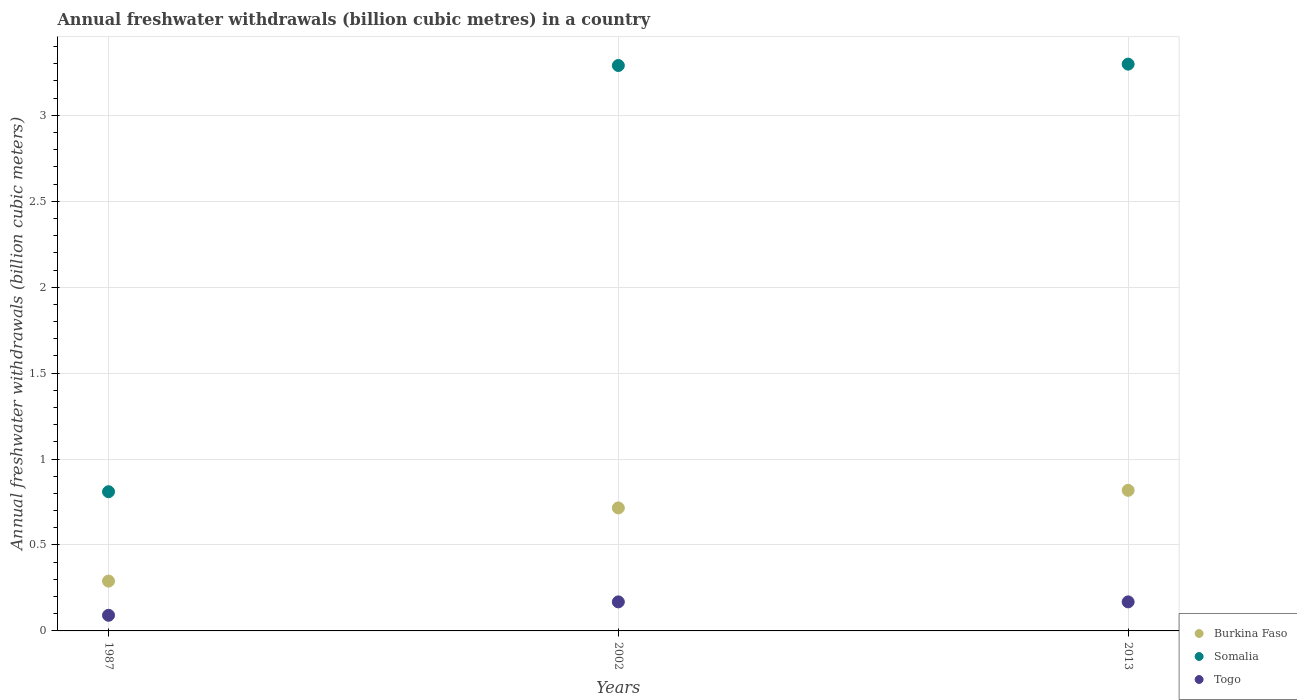What is the annual freshwater withdrawals in Burkina Faso in 2013?
Provide a succinct answer. 0.82. Across all years, what is the maximum annual freshwater withdrawals in Burkina Faso?
Offer a very short reply. 0.82. Across all years, what is the minimum annual freshwater withdrawals in Somalia?
Your answer should be very brief. 0.81. What is the total annual freshwater withdrawals in Somalia in the graph?
Provide a short and direct response. 7.4. What is the difference between the annual freshwater withdrawals in Somalia in 1987 and that in 2002?
Provide a succinct answer. -2.48. What is the difference between the annual freshwater withdrawals in Somalia in 2002 and the annual freshwater withdrawals in Togo in 2013?
Offer a very short reply. 3.12. What is the average annual freshwater withdrawals in Somalia per year?
Your answer should be compact. 2.47. In the year 2013, what is the difference between the annual freshwater withdrawals in Somalia and annual freshwater withdrawals in Togo?
Give a very brief answer. 3.13. What is the ratio of the annual freshwater withdrawals in Burkina Faso in 2002 to that in 2013?
Offer a very short reply. 0.87. Is the annual freshwater withdrawals in Somalia in 1987 less than that in 2002?
Your response must be concise. Yes. Is the difference between the annual freshwater withdrawals in Somalia in 1987 and 2013 greater than the difference between the annual freshwater withdrawals in Togo in 1987 and 2013?
Offer a terse response. No. What is the difference between the highest and the second highest annual freshwater withdrawals in Togo?
Offer a very short reply. 0. What is the difference between the highest and the lowest annual freshwater withdrawals in Togo?
Offer a very short reply. 0.08. In how many years, is the annual freshwater withdrawals in Somalia greater than the average annual freshwater withdrawals in Somalia taken over all years?
Give a very brief answer. 2. Is the annual freshwater withdrawals in Somalia strictly greater than the annual freshwater withdrawals in Burkina Faso over the years?
Offer a very short reply. Yes. How many years are there in the graph?
Give a very brief answer. 3. What is the difference between two consecutive major ticks on the Y-axis?
Offer a very short reply. 0.5. Are the values on the major ticks of Y-axis written in scientific E-notation?
Your answer should be very brief. No. Does the graph contain any zero values?
Your answer should be compact. No. Does the graph contain grids?
Ensure brevity in your answer.  Yes. What is the title of the graph?
Make the answer very short. Annual freshwater withdrawals (billion cubic metres) in a country. Does "Ireland" appear as one of the legend labels in the graph?
Your response must be concise. No. What is the label or title of the Y-axis?
Provide a short and direct response. Annual freshwater withdrawals (billion cubic meters). What is the Annual freshwater withdrawals (billion cubic meters) in Burkina Faso in 1987?
Make the answer very short. 0.29. What is the Annual freshwater withdrawals (billion cubic meters) of Somalia in 1987?
Offer a very short reply. 0.81. What is the Annual freshwater withdrawals (billion cubic meters) in Togo in 1987?
Keep it short and to the point. 0.09. What is the Annual freshwater withdrawals (billion cubic meters) in Burkina Faso in 2002?
Ensure brevity in your answer.  0.72. What is the Annual freshwater withdrawals (billion cubic meters) of Somalia in 2002?
Give a very brief answer. 3.29. What is the Annual freshwater withdrawals (billion cubic meters) in Togo in 2002?
Offer a terse response. 0.17. What is the Annual freshwater withdrawals (billion cubic meters) of Burkina Faso in 2013?
Provide a succinct answer. 0.82. What is the Annual freshwater withdrawals (billion cubic meters) of Somalia in 2013?
Your answer should be very brief. 3.3. What is the Annual freshwater withdrawals (billion cubic meters) of Togo in 2013?
Your answer should be very brief. 0.17. Across all years, what is the maximum Annual freshwater withdrawals (billion cubic meters) of Burkina Faso?
Provide a short and direct response. 0.82. Across all years, what is the maximum Annual freshwater withdrawals (billion cubic meters) of Somalia?
Your response must be concise. 3.3. Across all years, what is the maximum Annual freshwater withdrawals (billion cubic meters) of Togo?
Your answer should be very brief. 0.17. Across all years, what is the minimum Annual freshwater withdrawals (billion cubic meters) of Burkina Faso?
Provide a short and direct response. 0.29. Across all years, what is the minimum Annual freshwater withdrawals (billion cubic meters) of Somalia?
Ensure brevity in your answer.  0.81. Across all years, what is the minimum Annual freshwater withdrawals (billion cubic meters) in Togo?
Provide a succinct answer. 0.09. What is the total Annual freshwater withdrawals (billion cubic meters) in Burkina Faso in the graph?
Your response must be concise. 1.82. What is the total Annual freshwater withdrawals (billion cubic meters) of Somalia in the graph?
Your answer should be very brief. 7.4. What is the total Annual freshwater withdrawals (billion cubic meters) in Togo in the graph?
Keep it short and to the point. 0.43. What is the difference between the Annual freshwater withdrawals (billion cubic meters) of Burkina Faso in 1987 and that in 2002?
Keep it short and to the point. -0.43. What is the difference between the Annual freshwater withdrawals (billion cubic meters) of Somalia in 1987 and that in 2002?
Your answer should be compact. -2.48. What is the difference between the Annual freshwater withdrawals (billion cubic meters) of Togo in 1987 and that in 2002?
Your answer should be very brief. -0.08. What is the difference between the Annual freshwater withdrawals (billion cubic meters) of Burkina Faso in 1987 and that in 2013?
Offer a very short reply. -0.53. What is the difference between the Annual freshwater withdrawals (billion cubic meters) of Somalia in 1987 and that in 2013?
Keep it short and to the point. -2.49. What is the difference between the Annual freshwater withdrawals (billion cubic meters) of Togo in 1987 and that in 2013?
Your answer should be compact. -0.08. What is the difference between the Annual freshwater withdrawals (billion cubic meters) of Burkina Faso in 2002 and that in 2013?
Provide a succinct answer. -0.1. What is the difference between the Annual freshwater withdrawals (billion cubic meters) in Somalia in 2002 and that in 2013?
Your answer should be very brief. -0.01. What is the difference between the Annual freshwater withdrawals (billion cubic meters) of Togo in 2002 and that in 2013?
Give a very brief answer. 0. What is the difference between the Annual freshwater withdrawals (billion cubic meters) of Burkina Faso in 1987 and the Annual freshwater withdrawals (billion cubic meters) of Somalia in 2002?
Make the answer very short. -3. What is the difference between the Annual freshwater withdrawals (billion cubic meters) in Burkina Faso in 1987 and the Annual freshwater withdrawals (billion cubic meters) in Togo in 2002?
Provide a succinct answer. 0.12. What is the difference between the Annual freshwater withdrawals (billion cubic meters) in Somalia in 1987 and the Annual freshwater withdrawals (billion cubic meters) in Togo in 2002?
Your answer should be very brief. 0.64. What is the difference between the Annual freshwater withdrawals (billion cubic meters) in Burkina Faso in 1987 and the Annual freshwater withdrawals (billion cubic meters) in Somalia in 2013?
Make the answer very short. -3.01. What is the difference between the Annual freshwater withdrawals (billion cubic meters) of Burkina Faso in 1987 and the Annual freshwater withdrawals (billion cubic meters) of Togo in 2013?
Keep it short and to the point. 0.12. What is the difference between the Annual freshwater withdrawals (billion cubic meters) in Somalia in 1987 and the Annual freshwater withdrawals (billion cubic meters) in Togo in 2013?
Your answer should be compact. 0.64. What is the difference between the Annual freshwater withdrawals (billion cubic meters) of Burkina Faso in 2002 and the Annual freshwater withdrawals (billion cubic meters) of Somalia in 2013?
Offer a very short reply. -2.58. What is the difference between the Annual freshwater withdrawals (billion cubic meters) in Burkina Faso in 2002 and the Annual freshwater withdrawals (billion cubic meters) in Togo in 2013?
Keep it short and to the point. 0.55. What is the difference between the Annual freshwater withdrawals (billion cubic meters) of Somalia in 2002 and the Annual freshwater withdrawals (billion cubic meters) of Togo in 2013?
Provide a short and direct response. 3.12. What is the average Annual freshwater withdrawals (billion cubic meters) of Burkina Faso per year?
Ensure brevity in your answer.  0.61. What is the average Annual freshwater withdrawals (billion cubic meters) in Somalia per year?
Offer a very short reply. 2.47. What is the average Annual freshwater withdrawals (billion cubic meters) of Togo per year?
Give a very brief answer. 0.14. In the year 1987, what is the difference between the Annual freshwater withdrawals (billion cubic meters) in Burkina Faso and Annual freshwater withdrawals (billion cubic meters) in Somalia?
Make the answer very short. -0.52. In the year 1987, what is the difference between the Annual freshwater withdrawals (billion cubic meters) of Burkina Faso and Annual freshwater withdrawals (billion cubic meters) of Togo?
Offer a very short reply. 0.2. In the year 1987, what is the difference between the Annual freshwater withdrawals (billion cubic meters) in Somalia and Annual freshwater withdrawals (billion cubic meters) in Togo?
Offer a terse response. 0.72. In the year 2002, what is the difference between the Annual freshwater withdrawals (billion cubic meters) in Burkina Faso and Annual freshwater withdrawals (billion cubic meters) in Somalia?
Keep it short and to the point. -2.57. In the year 2002, what is the difference between the Annual freshwater withdrawals (billion cubic meters) in Burkina Faso and Annual freshwater withdrawals (billion cubic meters) in Togo?
Offer a terse response. 0.55. In the year 2002, what is the difference between the Annual freshwater withdrawals (billion cubic meters) of Somalia and Annual freshwater withdrawals (billion cubic meters) of Togo?
Your answer should be very brief. 3.12. In the year 2013, what is the difference between the Annual freshwater withdrawals (billion cubic meters) of Burkina Faso and Annual freshwater withdrawals (billion cubic meters) of Somalia?
Offer a terse response. -2.48. In the year 2013, what is the difference between the Annual freshwater withdrawals (billion cubic meters) of Burkina Faso and Annual freshwater withdrawals (billion cubic meters) of Togo?
Your answer should be compact. 0.65. In the year 2013, what is the difference between the Annual freshwater withdrawals (billion cubic meters) of Somalia and Annual freshwater withdrawals (billion cubic meters) of Togo?
Your answer should be very brief. 3.13. What is the ratio of the Annual freshwater withdrawals (billion cubic meters) in Burkina Faso in 1987 to that in 2002?
Your answer should be very brief. 0.41. What is the ratio of the Annual freshwater withdrawals (billion cubic meters) in Somalia in 1987 to that in 2002?
Keep it short and to the point. 0.25. What is the ratio of the Annual freshwater withdrawals (billion cubic meters) in Togo in 1987 to that in 2002?
Keep it short and to the point. 0.54. What is the ratio of the Annual freshwater withdrawals (billion cubic meters) in Burkina Faso in 1987 to that in 2013?
Offer a terse response. 0.35. What is the ratio of the Annual freshwater withdrawals (billion cubic meters) in Somalia in 1987 to that in 2013?
Your answer should be very brief. 0.25. What is the ratio of the Annual freshwater withdrawals (billion cubic meters) in Togo in 1987 to that in 2013?
Offer a very short reply. 0.54. What is the ratio of the Annual freshwater withdrawals (billion cubic meters) in Burkina Faso in 2002 to that in 2013?
Ensure brevity in your answer.  0.87. What is the ratio of the Annual freshwater withdrawals (billion cubic meters) in Togo in 2002 to that in 2013?
Provide a short and direct response. 1. What is the difference between the highest and the second highest Annual freshwater withdrawals (billion cubic meters) of Burkina Faso?
Make the answer very short. 0.1. What is the difference between the highest and the second highest Annual freshwater withdrawals (billion cubic meters) in Somalia?
Your response must be concise. 0.01. What is the difference between the highest and the lowest Annual freshwater withdrawals (billion cubic meters) in Burkina Faso?
Your answer should be very brief. 0.53. What is the difference between the highest and the lowest Annual freshwater withdrawals (billion cubic meters) in Somalia?
Offer a terse response. 2.49. What is the difference between the highest and the lowest Annual freshwater withdrawals (billion cubic meters) in Togo?
Your answer should be compact. 0.08. 